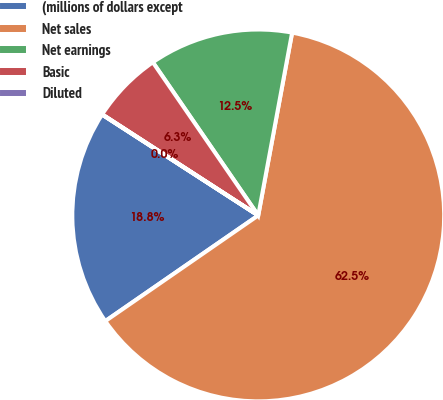<chart> <loc_0><loc_0><loc_500><loc_500><pie_chart><fcel>(millions of dollars except<fcel>Net sales<fcel>Net earnings<fcel>Basic<fcel>Diluted<nl><fcel>18.75%<fcel>62.46%<fcel>12.51%<fcel>6.26%<fcel>0.02%<nl></chart> 